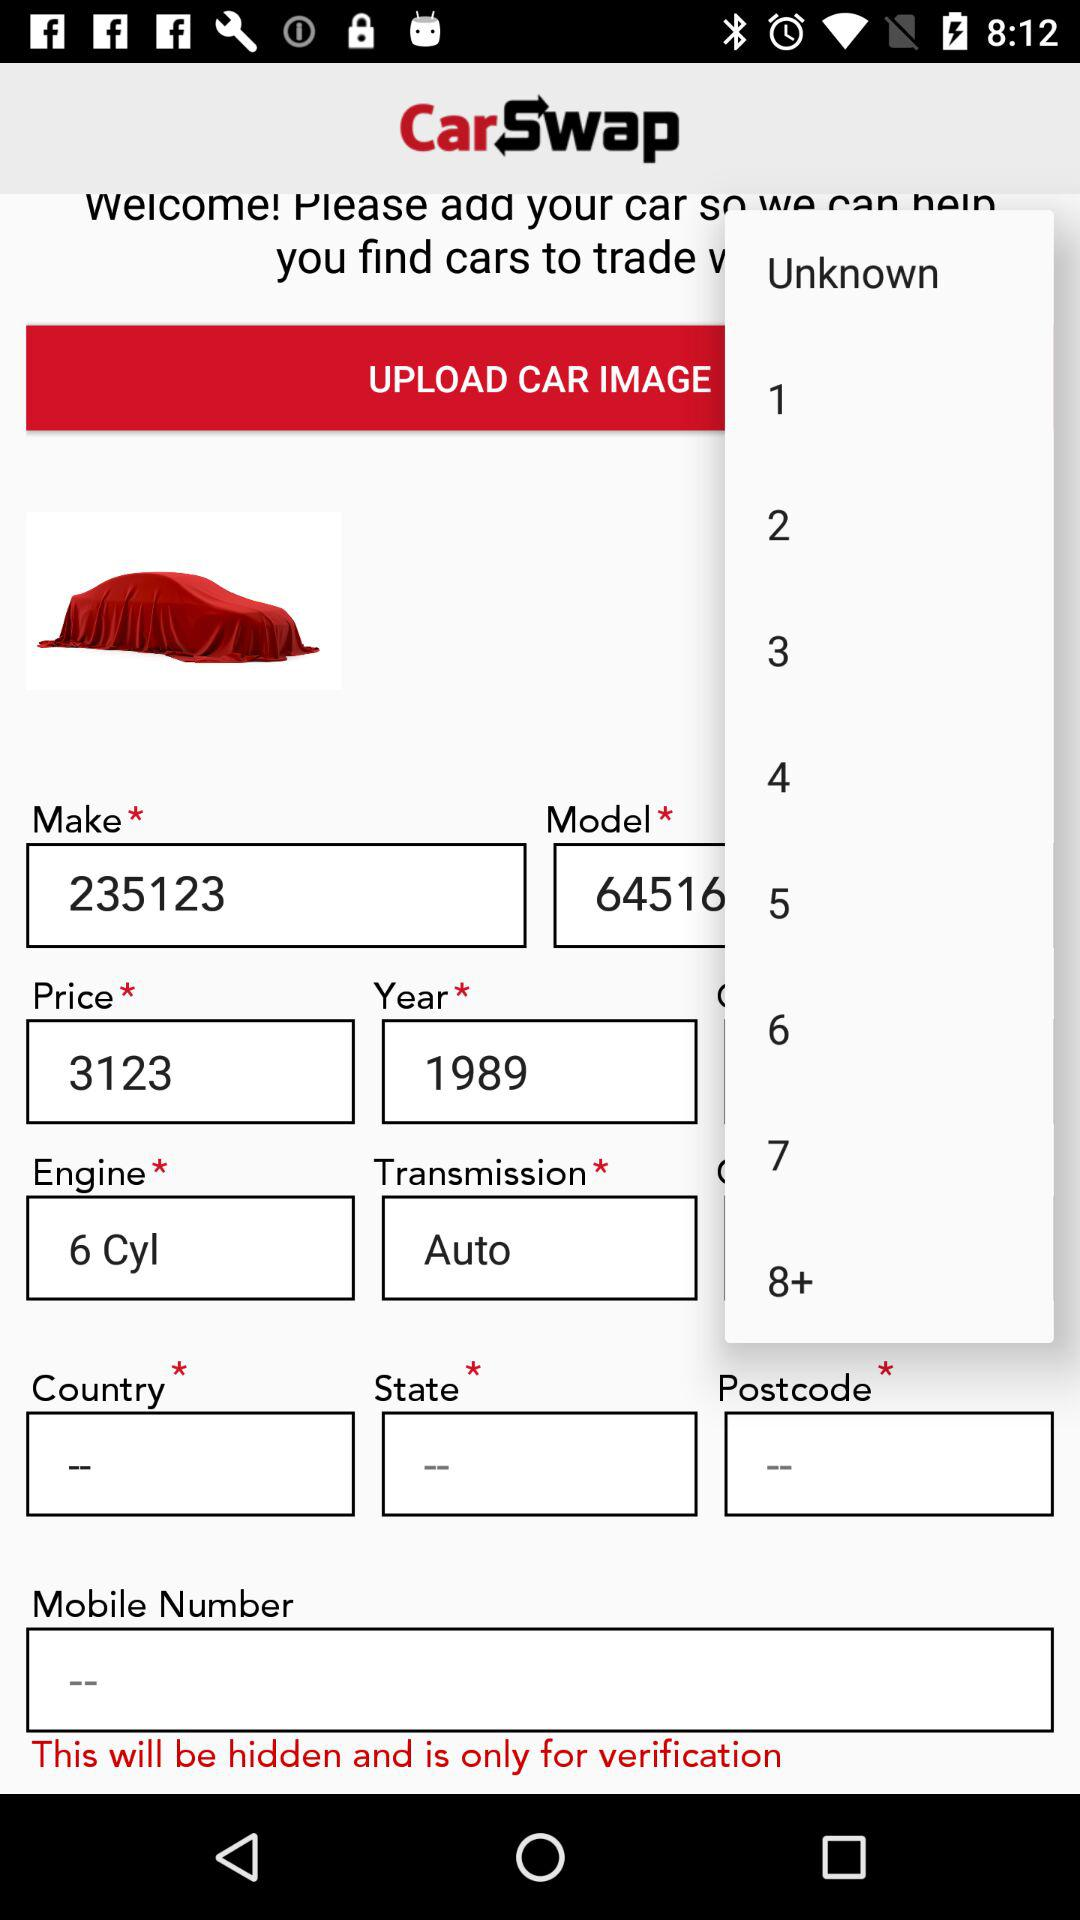What is the price? The price is 3123. 